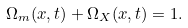<formula> <loc_0><loc_0><loc_500><loc_500>\Omega _ { m } ( x , t ) + \Omega _ { X } ( x , t ) = 1 .</formula> 